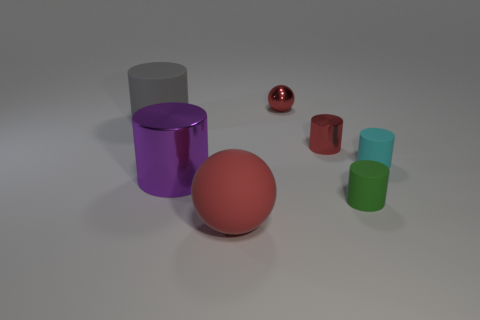Subtract all large cylinders. How many cylinders are left? 3 Subtract 2 spheres. How many spheres are left? 0 Subtract all green cylinders. Subtract all red blocks. How many cylinders are left? 4 Subtract all red matte objects. Subtract all big gray rubber things. How many objects are left? 5 Add 3 large red objects. How many large red objects are left? 4 Add 3 tiny spheres. How many tiny spheres exist? 4 Add 2 tiny cyan metal cylinders. How many objects exist? 9 Subtract all purple cylinders. How many cylinders are left? 4 Subtract 1 gray cylinders. How many objects are left? 6 Subtract all cylinders. How many objects are left? 2 